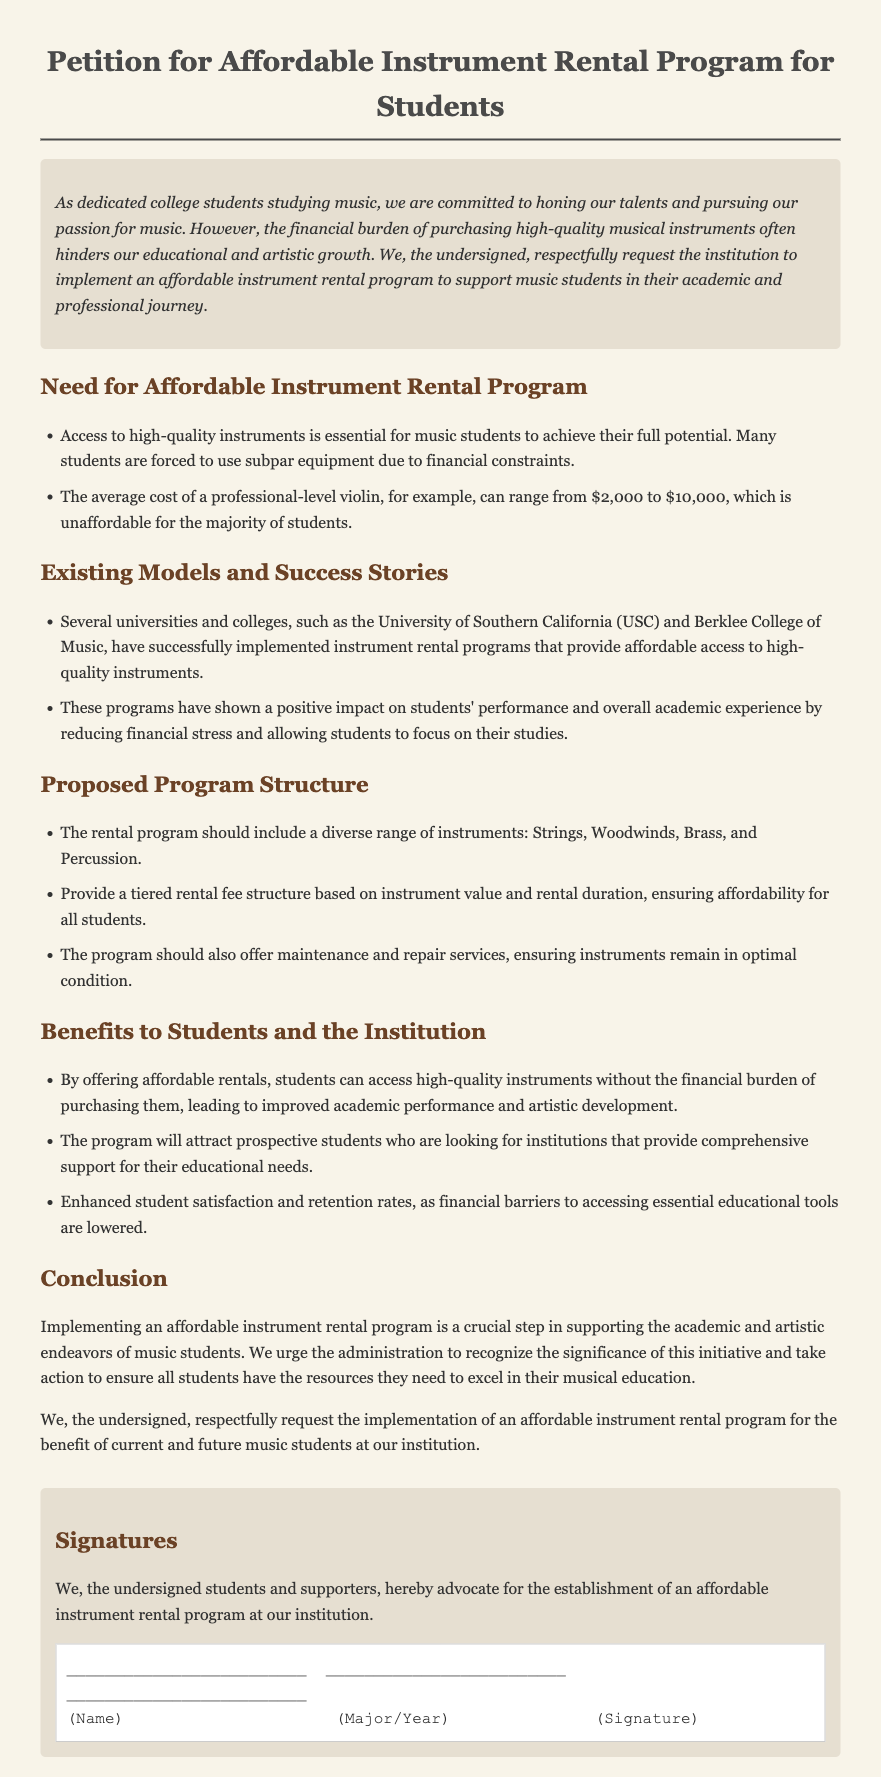What is the title of the petition? The title of the petition is provided at the top of the document.
Answer: Petition for Affordable Instrument Rental Program for Students What is one example of a high-cost instrument mentioned? The document lists specific instruments and their costs as examples of high-quality options.
Answer: Professional-level violin Which universities have successfully implemented instrument rental programs? The document mentions specific institutions that have successful rental programs.
Answer: University of Southern California and Berklee College of Music What rental structure is proposed in the petition? The petition outlines a specific structure for the rental program.
Answer: Tiered rental fee structure What benefit is mentioned for prospective students? The document states an advantage that the instrument rental program would have for attracting students.
Answer: Comprehensive support for their educational needs What is the primary conclusion of the petition? The conclusion summarizes the main request and outcome desired by the petitioners.
Answer: Implementing an affordable instrument rental program 